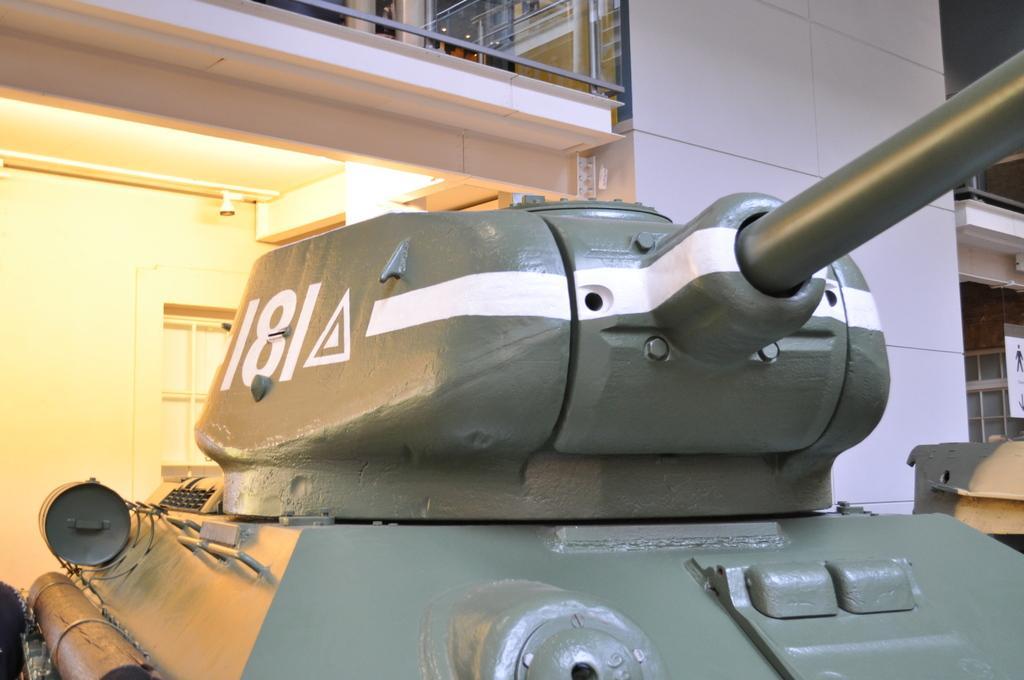How would you summarize this image in a sentence or two? In this image, in the middle, we can see a war equipment. On the right side, we can see a poster which is attached to a glass window, metal instrument. In the background, we can see glass window, building, wall. 